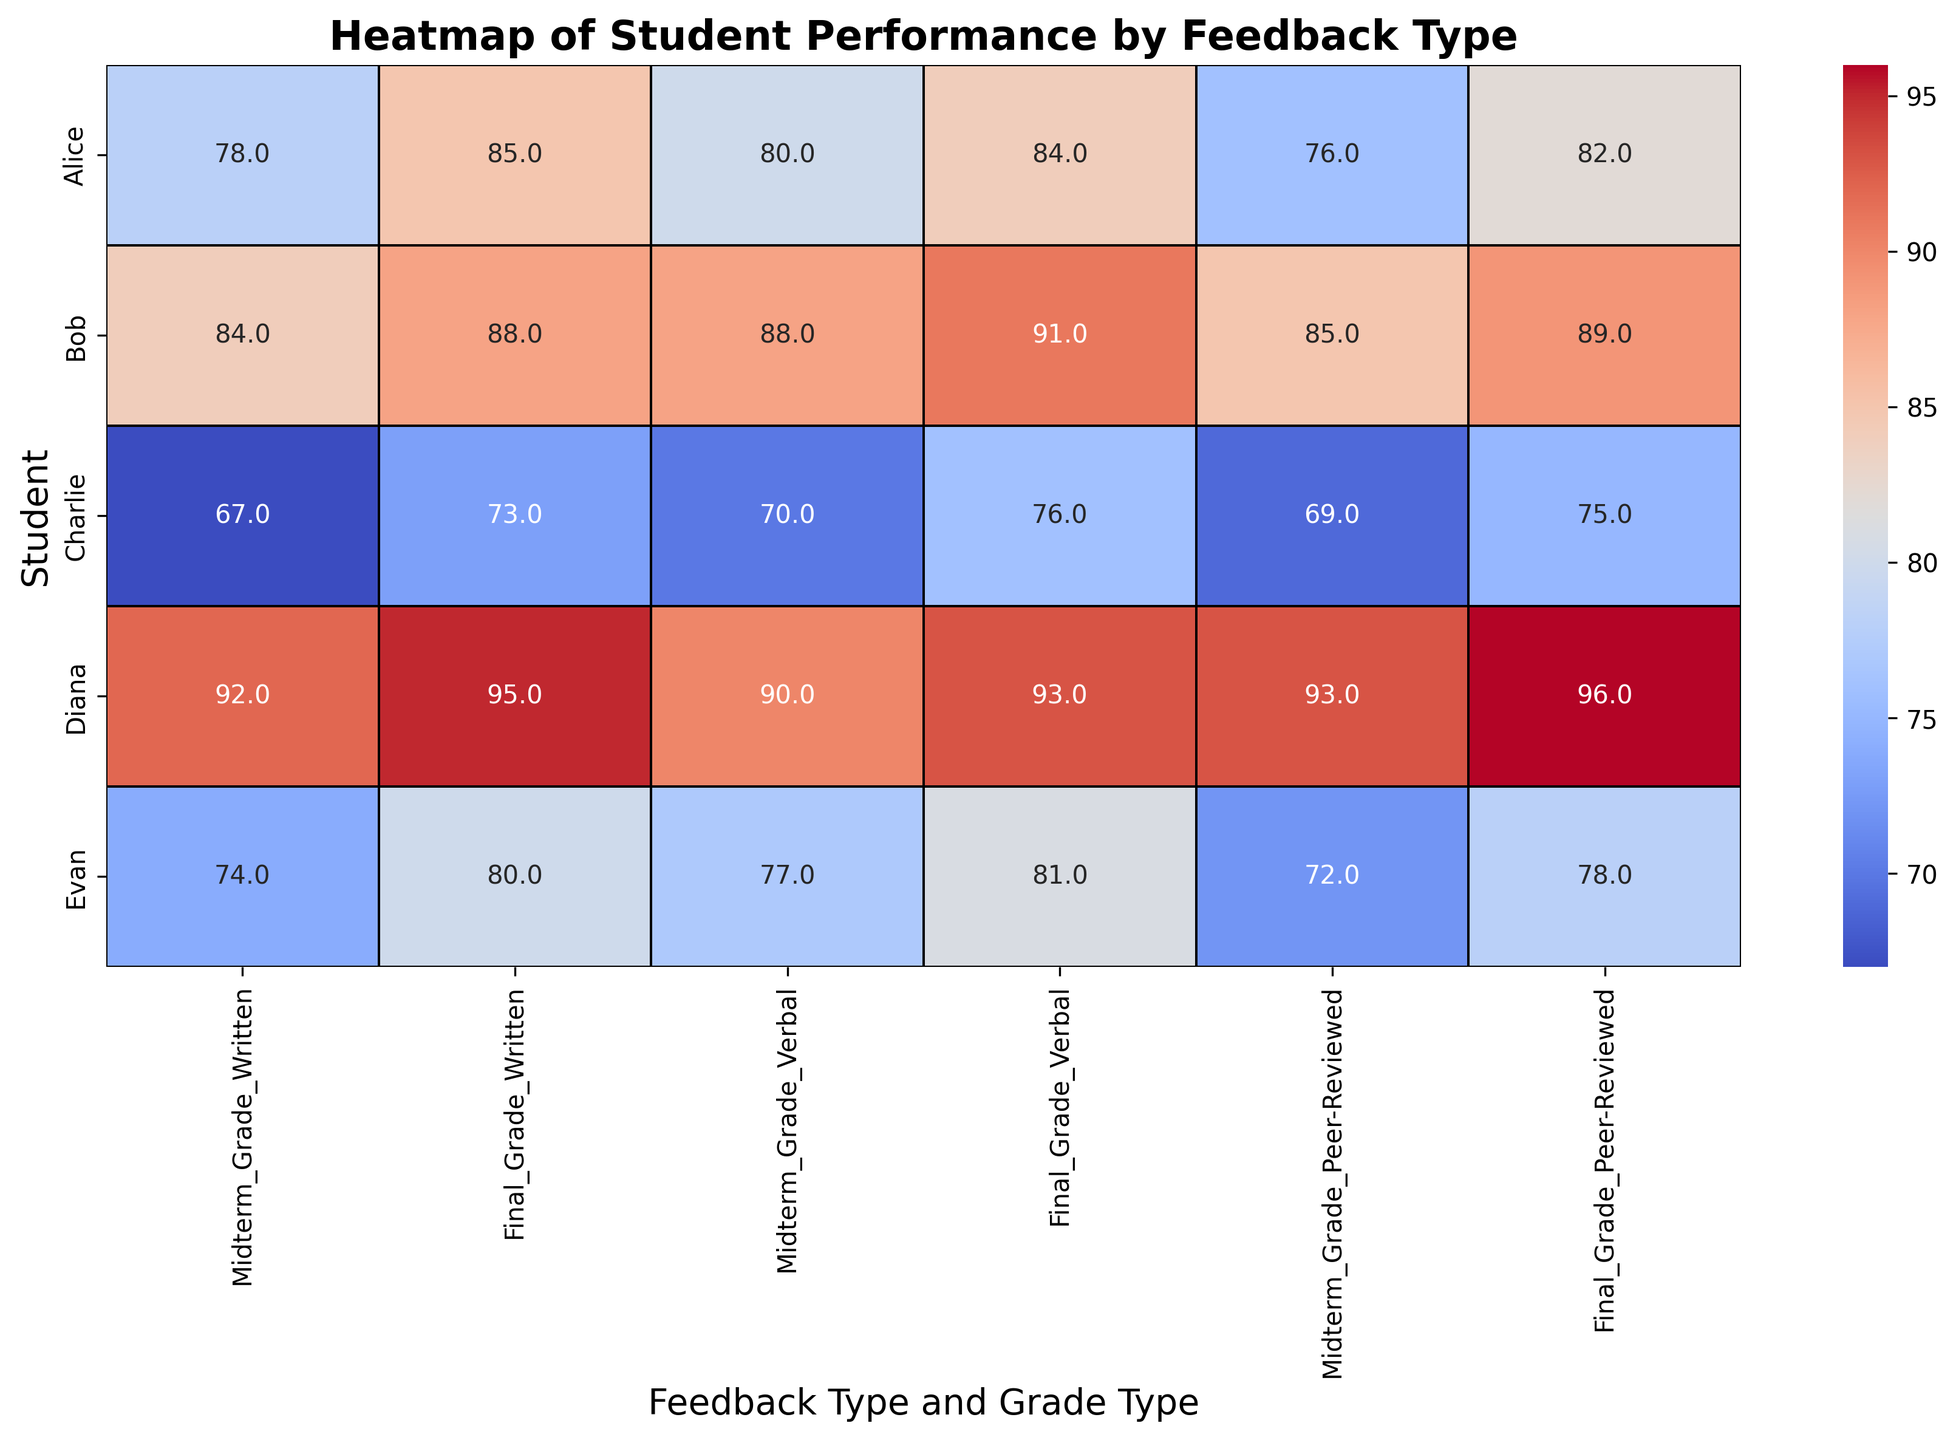What's the highest final grade for any feedback type? To identify the highest final grade, look at the final grade columns (Written, Verbal, Peer-Reviewed) and compare. The highest final grade, 96, appears for the Peer-Reviewed feedback type for Diana.
Answer: 96 Which student shows the greatest improvement from midterm to final grade for written feedback? Calculate the difference between midterm and final grades for the written feedback type for each student. The differences are: Alice (85-78=7), Bob (88-84=4), Charlie (73-67=6), Diana (95-92=3), Evan (80-74=6). The greatest improvement is for Alice, with a difference of 7.
Answer: Alice Does any student have the same final grade across all feedback types? Compare the final grades for each student across the three feedback types. No student has the same final grade across all feedback types.
Answer: No Which feedback type resulted in the highest average final grade? Calculate the average final grades for each feedback type: Written: (85+88+73+95+80)/5 = 84.2, Verbal: (84+91+76+93+81)/5 = 85, Peer-Reviewed: (82+89+75+96+78)/5 = 84. The highest average final grade is for Verbal feedback with an average of 85.
Answer: Verbal For which feedback type did Diana perform the best in the final grade? Look at the final grades for Diana across all feedback types: Written (95), Verbal (93), Peer-Reviewed (96). Diana performed the best in the Peer-Reviewed feedback type with a final grade of 96.
Answer: Peer-Reviewed What is the visual trend from midterm to final grades for Charlie across different feedback types? Observe the midterm and final grades for Charlie across written, verbal, and peer-reviewed feedback: Written (Mid: 67, Final: 73), Verbal (Mid: 70, Final: 76), Peer-Reviewed (Mid: 69, Final: 75). In all feedback types, Charlie's final grades are higher than his midterm grades, showing improvement.
Answer: Improvement across all feedback types Which student had the least variation in grades across the different feedback types? Calculate the range (max - min) of final grades for each student: Alice (85-82=3), Bob (91-88=3), Charlie (76-73=3), Diana (96-93=3), Evan (81-78=3). All students have the same variation in their final grades across different feedback types, which is 3.
Answer: All students Which feedback type appears to show the most consistent performance (smallest range) for midterm grades? Calculate the range (max - min) of midterm grades for each feedback type: Written: (92-67=25), Verbal: (90-70=20), Peer-Reviewed: (93-69=24). Verbal feedback type has the smallest range, indicating the most consistent performance in midterm grades.
Answer: Verbal 